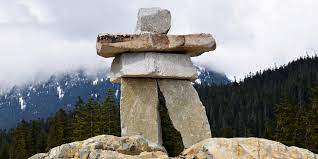How are Inukshuks built? Building an Inukshuk requires careful selection and balancing of stones. Each stone is chosen for its shape and fit, ensuring the structure is stable and enduring. Traditionally, they are built without using adhesives, relying only on the natural contours of the stones to balance and support each other. The process is not only a physical challenge but also a reflection of knowledge, skill, and respect for the land. 